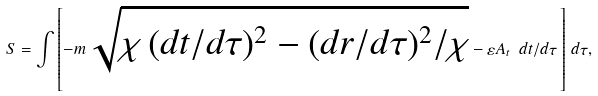Convert formula to latex. <formula><loc_0><loc_0><loc_500><loc_500>S = \int { \left [ - m \, \sqrt { \chi \, ( d t / d \tau ) ^ { 2 } - ( d r / d \tau ) ^ { 2 } / \chi } - \varepsilon A _ { t } \ d t / d \tau \, \right ] \, d \tau } ,</formula> 